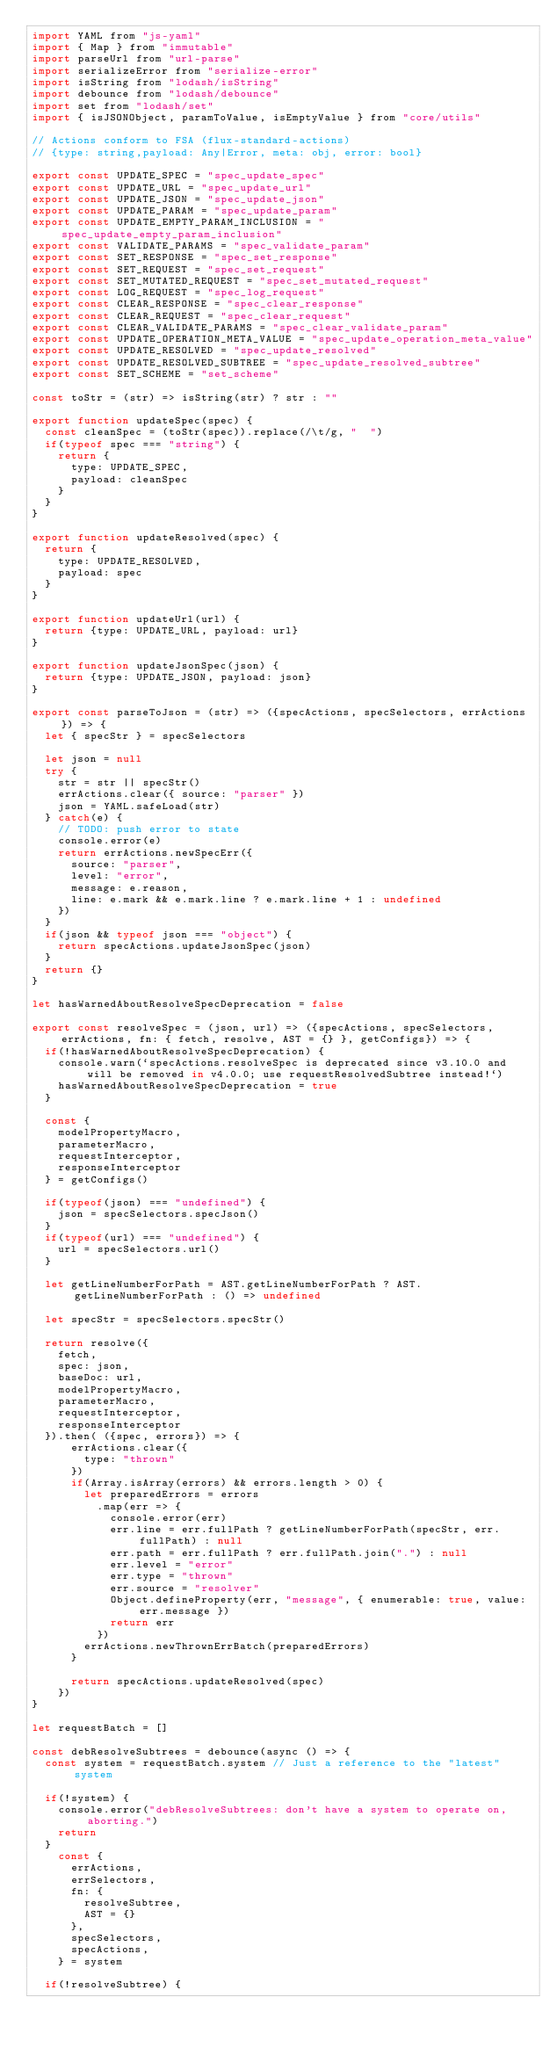Convert code to text. <code><loc_0><loc_0><loc_500><loc_500><_JavaScript_>import YAML from "js-yaml"
import { Map } from "immutable"
import parseUrl from "url-parse"
import serializeError from "serialize-error"
import isString from "lodash/isString"
import debounce from "lodash/debounce"
import set from "lodash/set"
import { isJSONObject, paramToValue, isEmptyValue } from "core/utils"

// Actions conform to FSA (flux-standard-actions)
// {type: string,payload: Any|Error, meta: obj, error: bool}

export const UPDATE_SPEC = "spec_update_spec"
export const UPDATE_URL = "spec_update_url"
export const UPDATE_JSON = "spec_update_json"
export const UPDATE_PARAM = "spec_update_param"
export const UPDATE_EMPTY_PARAM_INCLUSION = "spec_update_empty_param_inclusion"
export const VALIDATE_PARAMS = "spec_validate_param"
export const SET_RESPONSE = "spec_set_response"
export const SET_REQUEST = "spec_set_request"
export const SET_MUTATED_REQUEST = "spec_set_mutated_request"
export const LOG_REQUEST = "spec_log_request"
export const CLEAR_RESPONSE = "spec_clear_response"
export const CLEAR_REQUEST = "spec_clear_request"
export const CLEAR_VALIDATE_PARAMS = "spec_clear_validate_param"
export const UPDATE_OPERATION_META_VALUE = "spec_update_operation_meta_value"
export const UPDATE_RESOLVED = "spec_update_resolved"
export const UPDATE_RESOLVED_SUBTREE = "spec_update_resolved_subtree"
export const SET_SCHEME = "set_scheme"

const toStr = (str) => isString(str) ? str : ""

export function updateSpec(spec) {
  const cleanSpec = (toStr(spec)).replace(/\t/g, "  ")
  if(typeof spec === "string") {
    return {
      type: UPDATE_SPEC,
      payload: cleanSpec
    }
  }
}

export function updateResolved(spec) {
  return {
    type: UPDATE_RESOLVED,
    payload: spec
  }
}

export function updateUrl(url) {
  return {type: UPDATE_URL, payload: url}
}

export function updateJsonSpec(json) {
  return {type: UPDATE_JSON, payload: json}
}

export const parseToJson = (str) => ({specActions, specSelectors, errActions}) => {
  let { specStr } = specSelectors

  let json = null
  try {
    str = str || specStr()
    errActions.clear({ source: "parser" })
    json = YAML.safeLoad(str)
  } catch(e) {
    // TODO: push error to state
    console.error(e)
    return errActions.newSpecErr({
      source: "parser",
      level: "error",
      message: e.reason,
      line: e.mark && e.mark.line ? e.mark.line + 1 : undefined
    })
  }
  if(json && typeof json === "object") {
    return specActions.updateJsonSpec(json)
  }
  return {}
}

let hasWarnedAboutResolveSpecDeprecation = false

export const resolveSpec = (json, url) => ({specActions, specSelectors, errActions, fn: { fetch, resolve, AST = {} }, getConfigs}) => {
  if(!hasWarnedAboutResolveSpecDeprecation) {
    console.warn(`specActions.resolveSpec is deprecated since v3.10.0 and will be removed in v4.0.0; use requestResolvedSubtree instead!`)
    hasWarnedAboutResolveSpecDeprecation = true
  }

  const {
    modelPropertyMacro,
    parameterMacro,
    requestInterceptor,
    responseInterceptor
  } = getConfigs()

  if(typeof(json) === "undefined") {
    json = specSelectors.specJson()
  }
  if(typeof(url) === "undefined") {
    url = specSelectors.url()
  }

  let getLineNumberForPath = AST.getLineNumberForPath ? AST.getLineNumberForPath : () => undefined

  let specStr = specSelectors.specStr()

  return resolve({
    fetch,
    spec: json,
    baseDoc: url,
    modelPropertyMacro,
    parameterMacro,
    requestInterceptor,
    responseInterceptor
  }).then( ({spec, errors}) => {
      errActions.clear({
        type: "thrown"
      })
      if(Array.isArray(errors) && errors.length > 0) {
        let preparedErrors = errors
          .map(err => {
            console.error(err)
            err.line = err.fullPath ? getLineNumberForPath(specStr, err.fullPath) : null
            err.path = err.fullPath ? err.fullPath.join(".") : null
            err.level = "error"
            err.type = "thrown"
            err.source = "resolver"
            Object.defineProperty(err, "message", { enumerable: true, value: err.message })
            return err
          })
        errActions.newThrownErrBatch(preparedErrors)
      }

      return specActions.updateResolved(spec)
    })
}

let requestBatch = []

const debResolveSubtrees = debounce(async () => {
  const system = requestBatch.system // Just a reference to the "latest" system

  if(!system) {
    console.error("debResolveSubtrees: don't have a system to operate on, aborting.")
    return
  }
    const {
      errActions,
      errSelectors,
      fn: {
        resolveSubtree,
        AST = {}
      },
      specSelectors,
      specActions,
    } = system

  if(!resolveSubtree) {</code> 